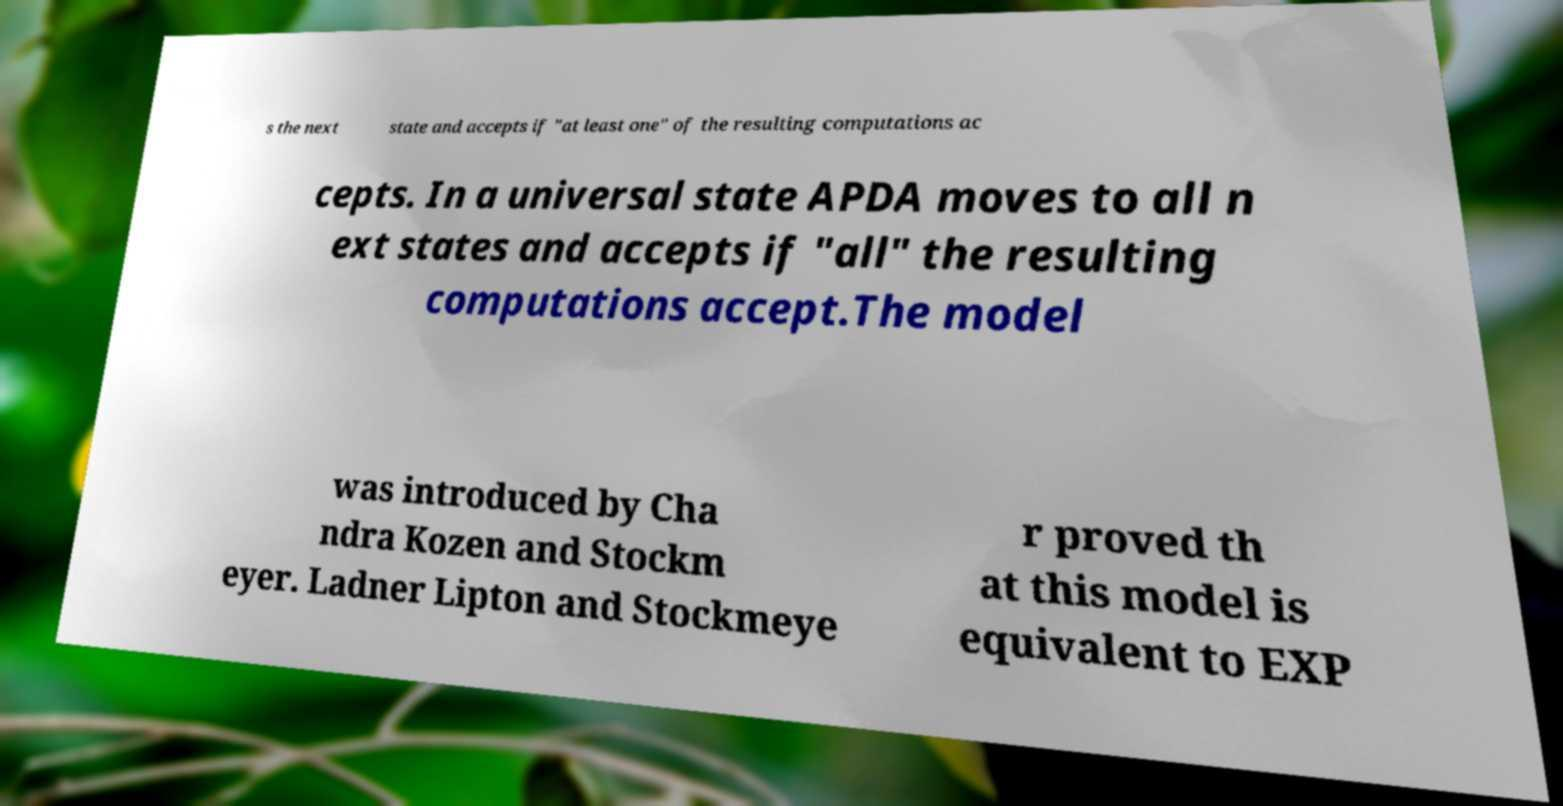There's text embedded in this image that I need extracted. Can you transcribe it verbatim? s the next state and accepts if "at least one" of the resulting computations ac cepts. In a universal state APDA moves to all n ext states and accepts if "all" the resulting computations accept.The model was introduced by Cha ndra Kozen and Stockm eyer. Ladner Lipton and Stockmeye r proved th at this model is equivalent to EXP 